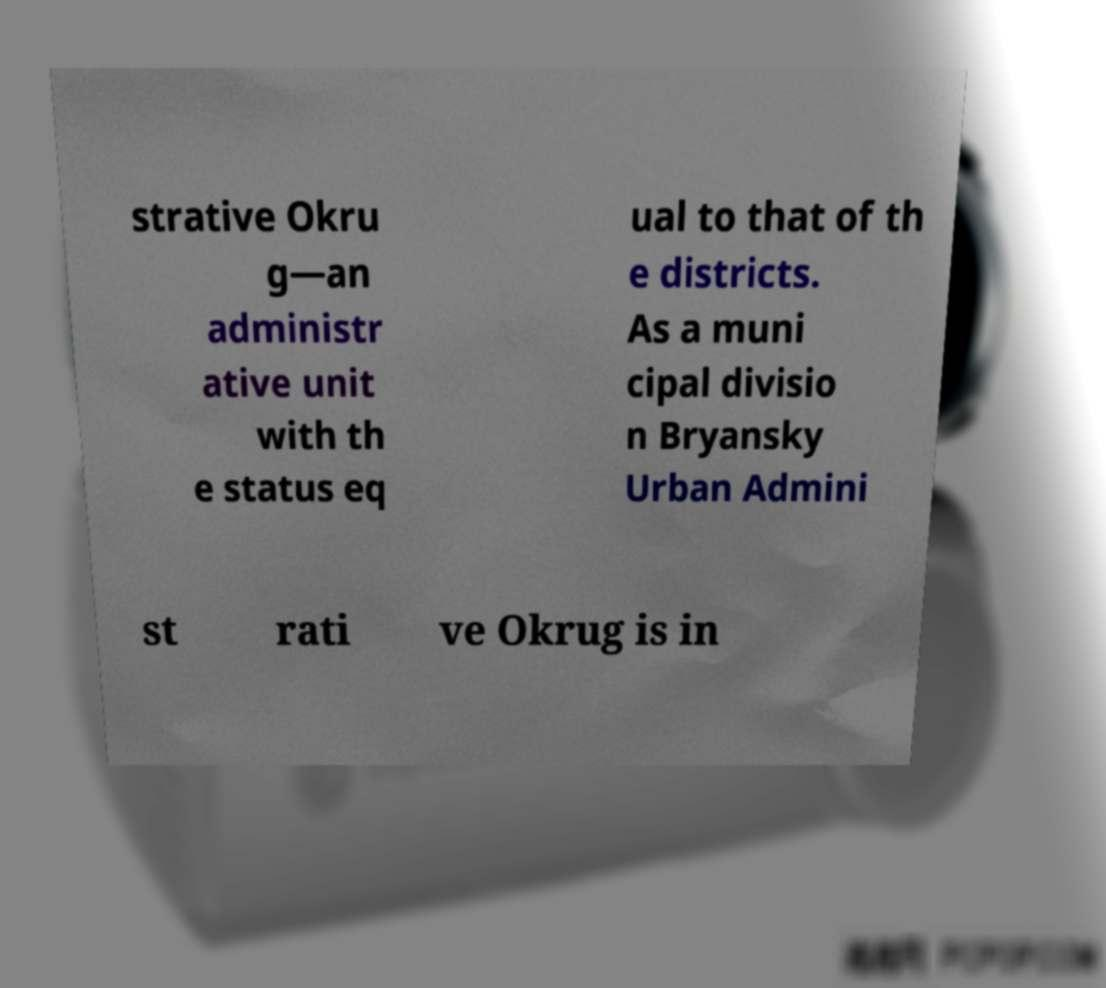Can you accurately transcribe the text from the provided image for me? strative Okru g—an administr ative unit with th e status eq ual to that of th e districts. As a muni cipal divisio n Bryansky Urban Admini st rati ve Okrug is in 